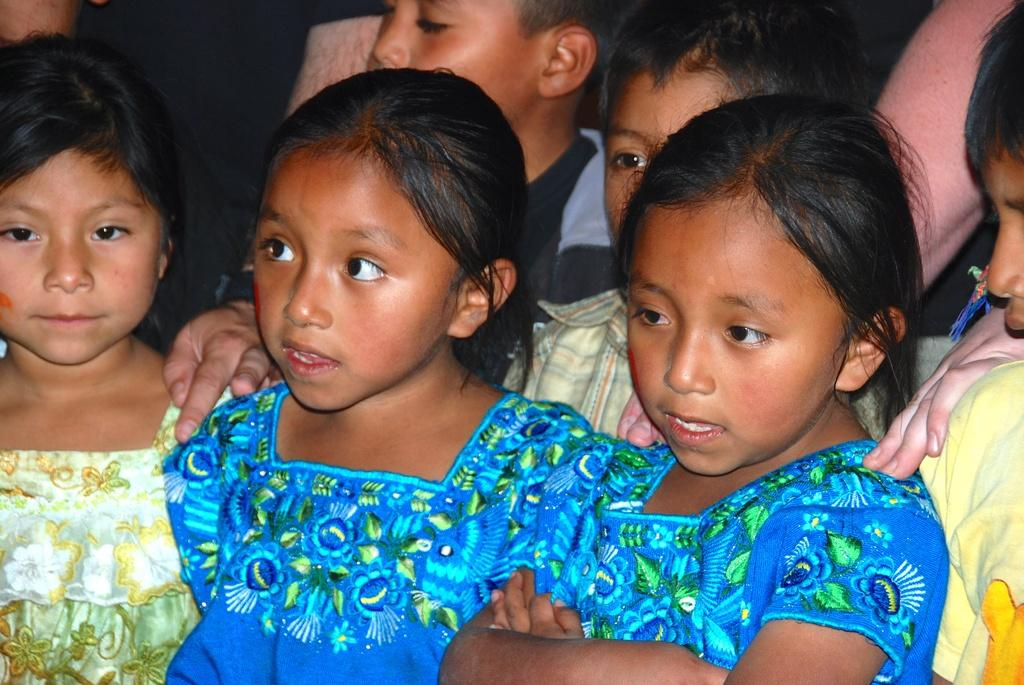How many kids are in the image? The number of kids in the image cannot be determined from the provided fact. What type of eggs are being served by the servant during the birthday party in the image? There is no information about eggs, a servant, or a birthday party in the image. 